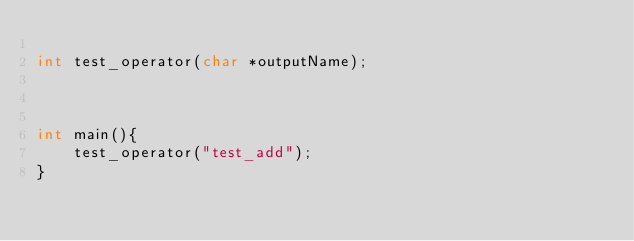Convert code to text. <code><loc_0><loc_0><loc_500><loc_500><_C_>
int test_operator(char *outputName);



int main(){
    test_operator("test_add");
}
</code> 